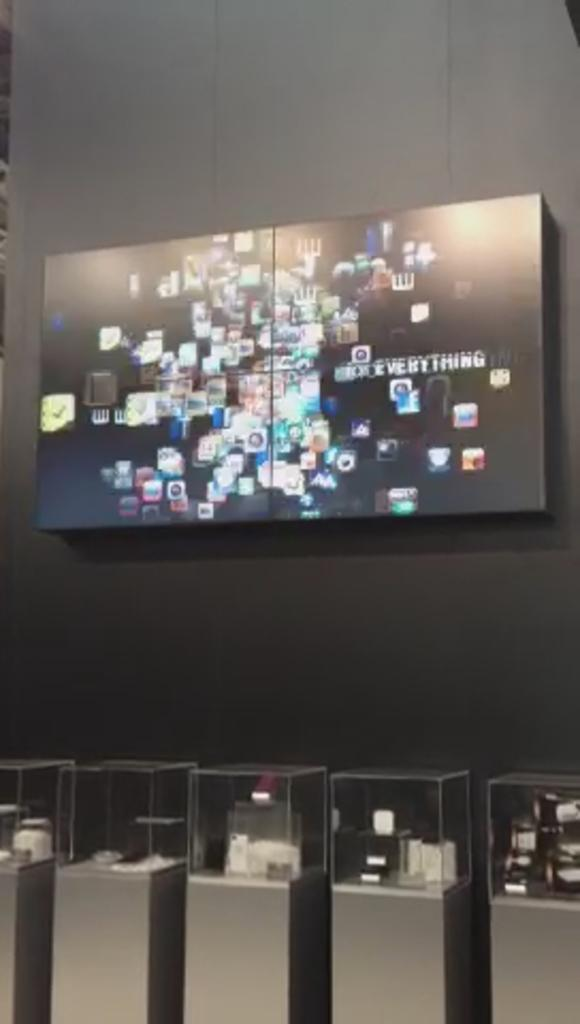<image>
Present a compact description of the photo's key features. Four screens pushed together to create a large image that features several icons and the word EVERYTHING in capital letters 